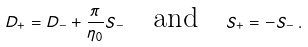<formula> <loc_0><loc_0><loc_500><loc_500>D _ { + } = D _ { - } + \frac { \pi } { \eta _ { 0 } } S _ { - } \quad \text {and} \quad S _ { + } = - S _ { - } \, .</formula> 